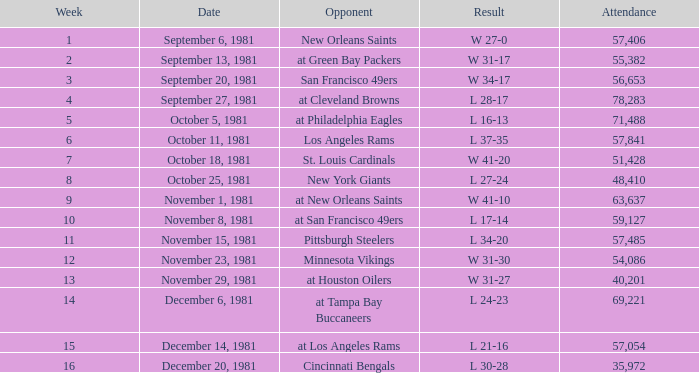On what date did the team play againt the New Orleans Saints? September 6, 1981. 